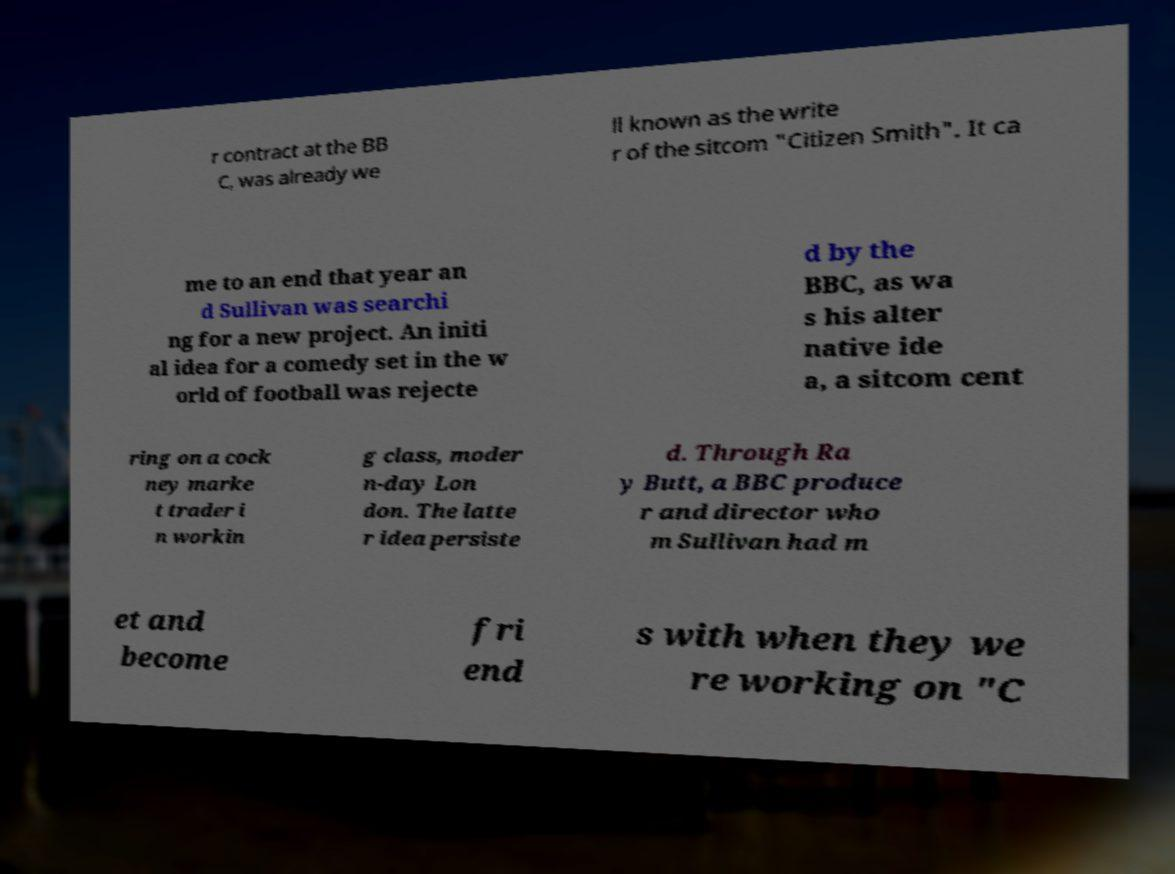Could you extract and type out the text from this image? r contract at the BB C, was already we ll known as the write r of the sitcom "Citizen Smith". It ca me to an end that year an d Sullivan was searchi ng for a new project. An initi al idea for a comedy set in the w orld of football was rejecte d by the BBC, as wa s his alter native ide a, a sitcom cent ring on a cock ney marke t trader i n workin g class, moder n-day Lon don. The latte r idea persiste d. Through Ra y Butt, a BBC produce r and director who m Sullivan had m et and become fri end s with when they we re working on "C 